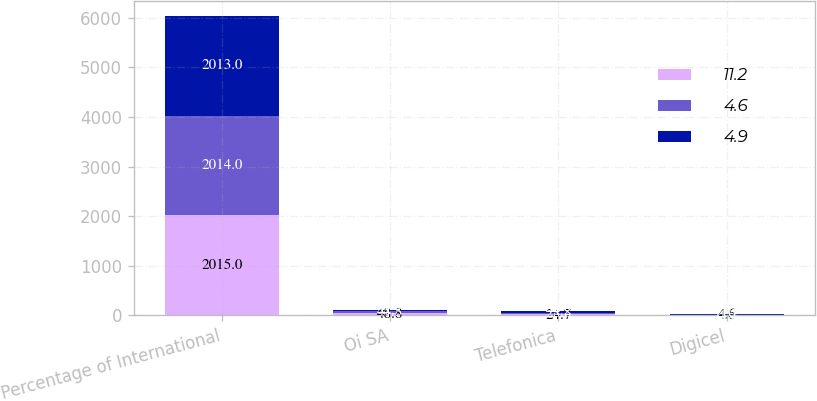<chart> <loc_0><loc_0><loc_500><loc_500><stacked_bar_chart><ecel><fcel>Percentage of International<fcel>Oi SA<fcel>Telefonica<fcel>Digicel<nl><fcel>11.2<fcel>2015<fcel>48.8<fcel>24.7<fcel>4.6<nl><fcel>4.6<fcel>2014<fcel>44.3<fcel>28.8<fcel>4.9<nl><fcel>4.9<fcel>2013<fcel>6.3<fcel>44.2<fcel>11.2<nl></chart> 